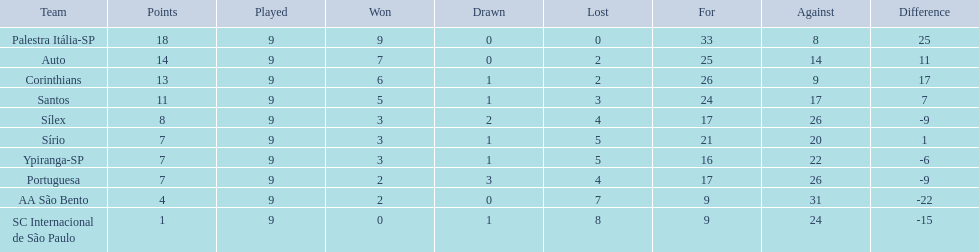How many games did each team play? 9, 9, 9, 9, 9, 9, 9, 9, 9, 9. Did any team score 13 points in the total games they played? 13. What is the name of that team? Corinthians. 